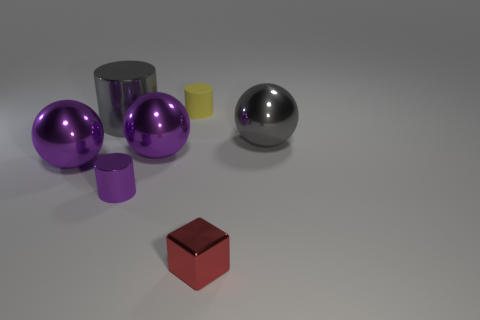There is a thing that is the same color as the large cylinder; what material is it?
Give a very brief answer. Metal. Do the gray shiny object right of the shiny cube and the rubber object behind the small metallic cylinder have the same size?
Provide a short and direct response. No. Is there any other thing that is made of the same material as the tiny yellow cylinder?
Make the answer very short. No. Is there any other thing that is the same color as the small metallic cylinder?
Make the answer very short. Yes. There is a tiny object that is behind the purple metal thing that is in front of the large purple shiny ball to the left of the tiny purple shiny thing; what is its material?
Provide a succinct answer. Rubber. What number of gray metal cylinders have the same size as the yellow object?
Your answer should be compact. 0. What is the cylinder that is in front of the yellow matte cylinder and right of the big cylinder made of?
Provide a succinct answer. Metal. There is a large gray shiny cylinder; what number of large balls are on the left side of it?
Give a very brief answer. 1. There is a matte object; is its shape the same as the large gray object that is left of the tiny red cube?
Make the answer very short. Yes. Are there any other tiny purple objects of the same shape as the matte thing?
Provide a succinct answer. Yes. 